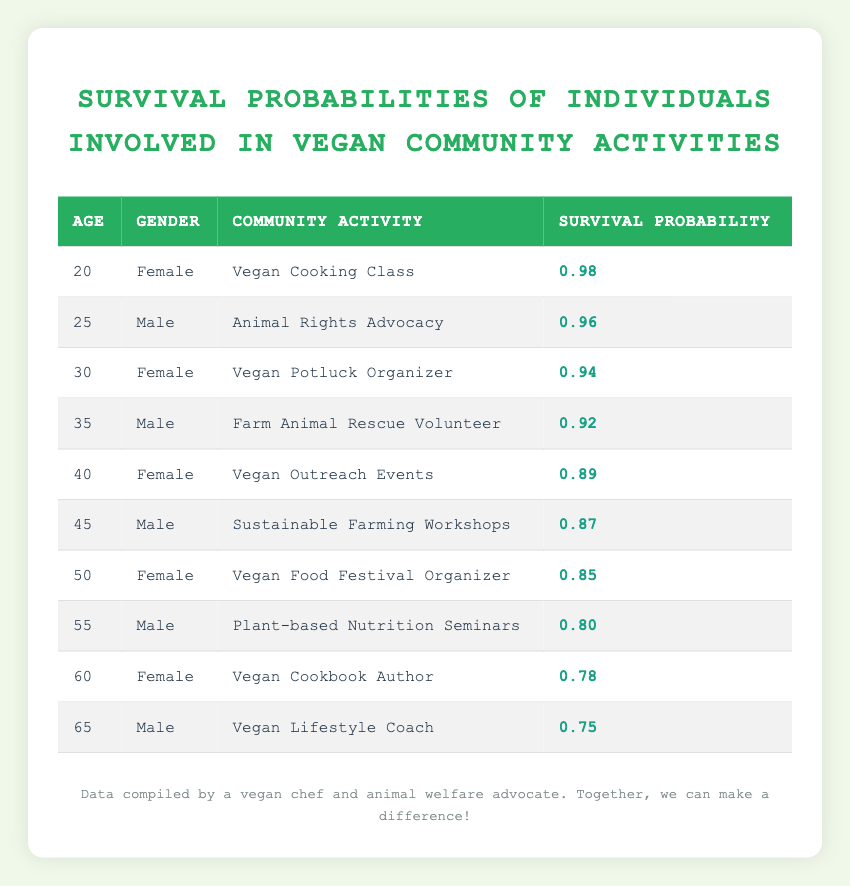What is the survival probability for a 40-year-old female involved in Vegan Outreach Events? Looking at the table, we find the row for a 40-year-old female with the community activity as Vegan Outreach Events. The corresponding survival probability in that row is 0.89.
Answer: 0.89 Which age group has the highest survival probability according to the table? The highest survival probability listed is 0.98 for a 20-year-old female participating in Vegan Cooking Class. Comparing the survival probabilities of all ages, 20 is the highest.
Answer: 20 What is the survival probability for a 55-year-old male? The table shows that a 55-year-old male involved in Plant-based Nutrition Seminars has a survival probability of 0.80.
Answer: 0.80 Is the survival probability for a 50-year-old female involved in Vegan Food Festival Organizer higher than that of a 60-year-old female? The survival probability for a 50-year-old female is 0.85 while that for the 60-year-old female is 0.78. Since 0.85 is greater than 0.78, the statement is true.
Answer: Yes What is the average survival probability for males in this table? Summing up the survival probabilities for males: 0.96 (25 years) + 0.92 (35 years) + 0.87 (45 years) + 0.80 (55 years) + 0.75 (65 years) = 4.3. There are 5 males, so the average is 4.3 / 5 = 0.86.
Answer: 0.86 Which community activity has the lowest survival probability? Looking through the table, the lowest survival probability is 0.75, which is associated with the 65-year-old male involved as a Vegan Lifestyle Coach.
Answer: Vegan Lifestyle Coach What is the difference in survival probability between a 30-year-old female and a 40-year-old female? A 30-year-old female has a survival probability of 0.94 and a 40-year-old female has a survival probability of 0.89. The difference is 0.94 - 0.89 = 0.05.
Answer: 0.05 Is it true that all community activities involving males have a survival probability above 0.80? The survival probabilities for males are: 0.96, 0.92, 0.87, 0.80, and 0.75. Since 0.75 is below 0.80, the statement is false.
Answer: No What is the survival probability for a 65-year-old male involved in Vegan Lifestyle Coaching? The survival probability listed for a 65-year-old male in that activity is 0.75 as seen in the corresponding table row.
Answer: 0.75 